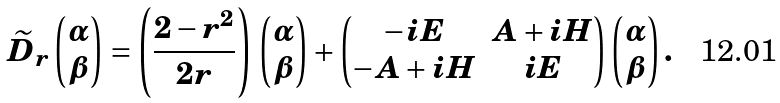Convert formula to latex. <formula><loc_0><loc_0><loc_500><loc_500>\widetilde { D } _ { r } \begin{pmatrix} \alpha \\ \beta \end{pmatrix} = \left ( \frac { 2 - r ^ { 2 } } { 2 r } \right ) \, \begin{pmatrix} \alpha \\ \beta \end{pmatrix} + \begin{pmatrix} - i E & A + i H \\ - A + i H & i E \end{pmatrix} \begin{pmatrix} \alpha \\ \beta \end{pmatrix} .</formula> 